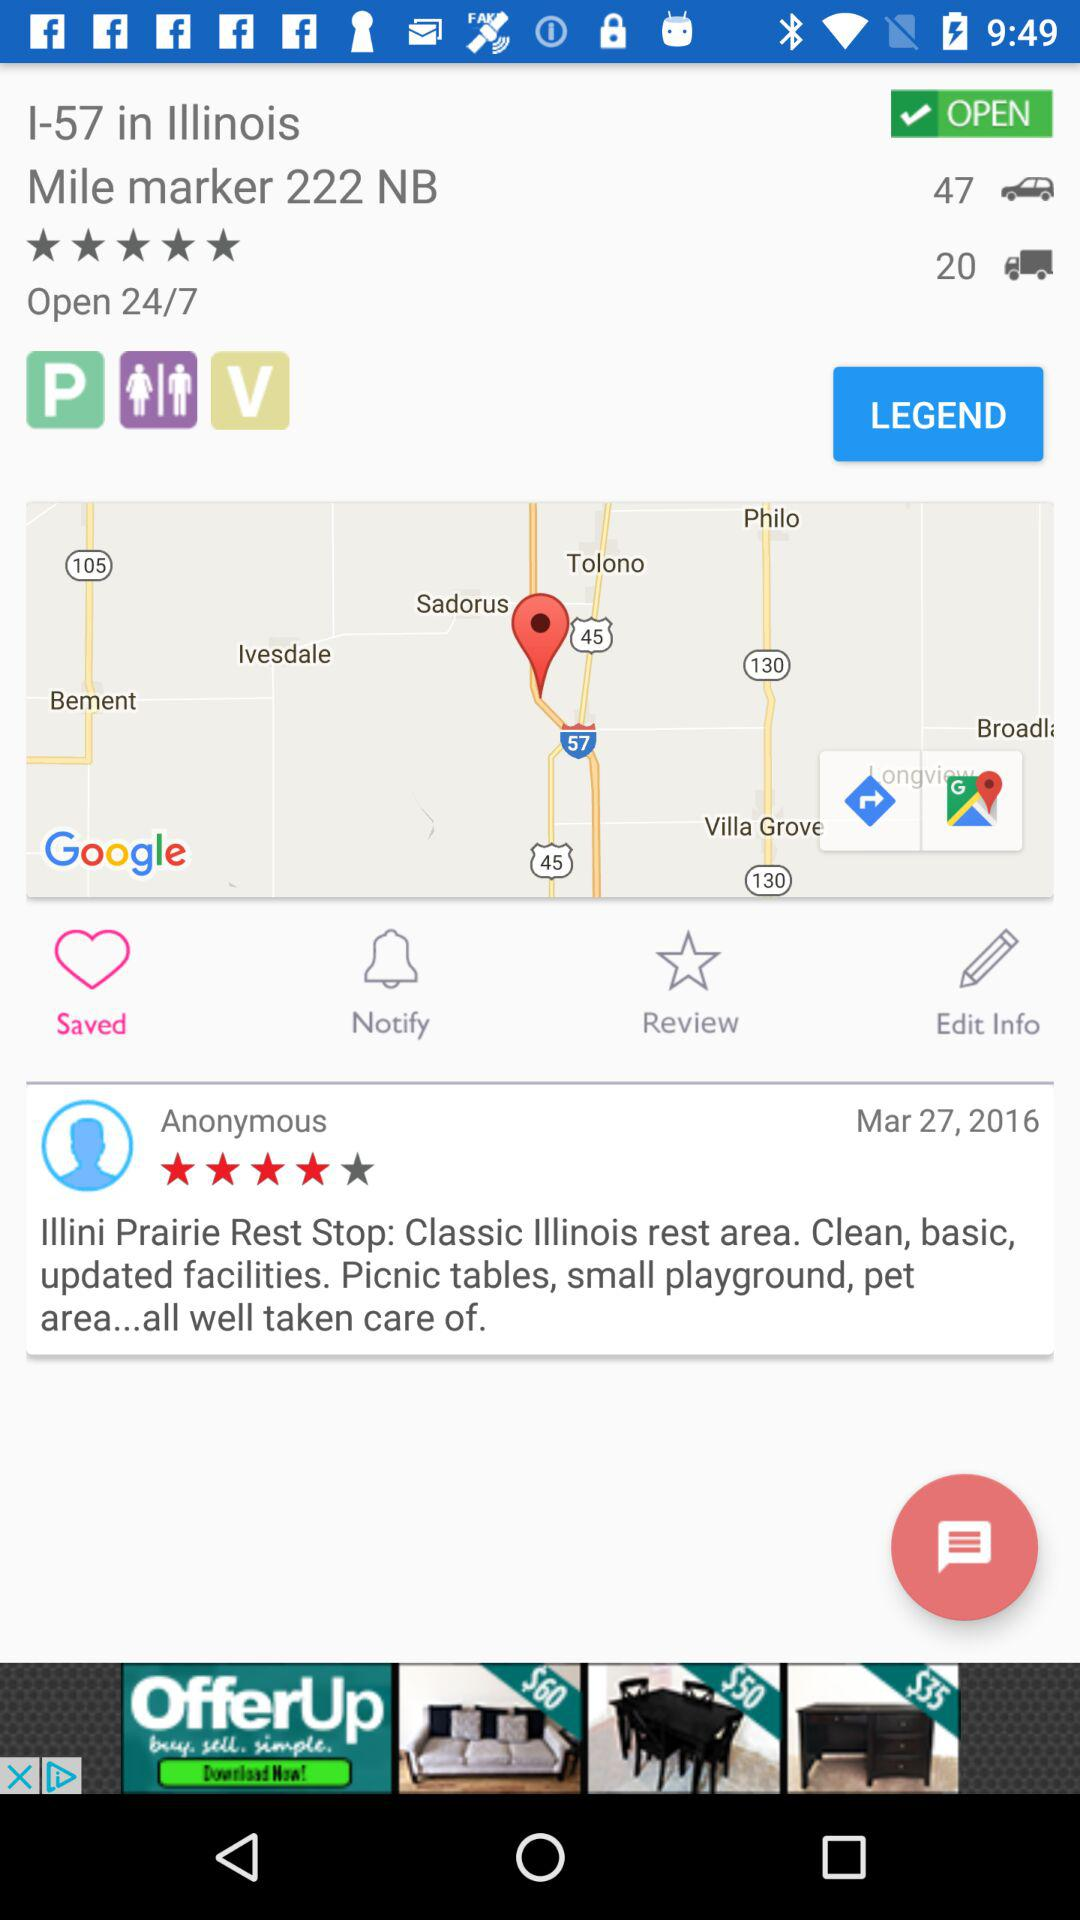How many stars did Anonymous give? Anonymous gave 4 stars. 